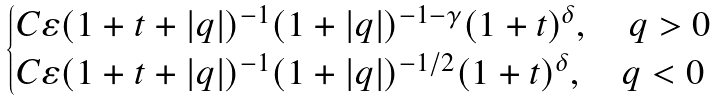Convert formula to latex. <formula><loc_0><loc_0><loc_500><loc_500>\begin{cases} C \varepsilon ( 1 + t + | q | ) ^ { - 1 } ( 1 + | q | ) ^ { - 1 - \gamma } ( 1 + t ) ^ { \delta } , \quad q > 0 \\ C \varepsilon ( 1 + t + | q | ) ^ { - 1 } ( 1 + | q | ) ^ { - 1 / 2 } ( 1 + t ) ^ { \delta } , \quad q < 0 \end{cases}</formula> 